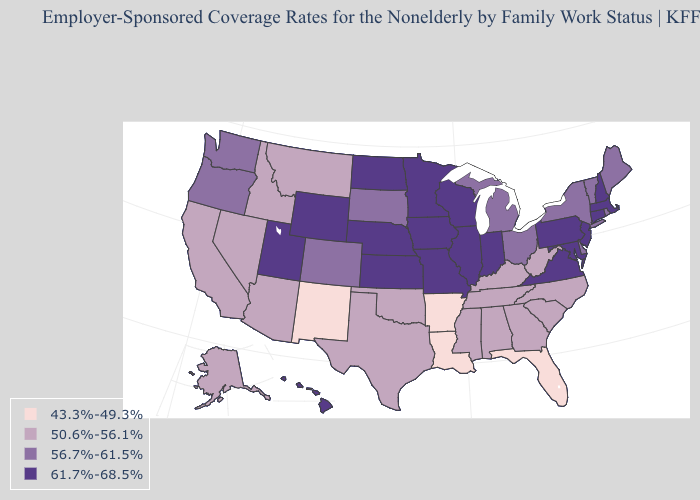What is the highest value in the USA?
Keep it brief. 61.7%-68.5%. What is the lowest value in the USA?
Be succinct. 43.3%-49.3%. Name the states that have a value in the range 61.7%-68.5%?
Quick response, please. Connecticut, Hawaii, Illinois, Indiana, Iowa, Kansas, Maryland, Massachusetts, Minnesota, Missouri, Nebraska, New Hampshire, New Jersey, North Dakota, Pennsylvania, Utah, Virginia, Wisconsin, Wyoming. Among the states that border Missouri , which have the highest value?
Write a very short answer. Illinois, Iowa, Kansas, Nebraska. What is the value of Alabama?
Write a very short answer. 50.6%-56.1%. Among the states that border Washington , does Idaho have the lowest value?
Answer briefly. Yes. What is the value of Kansas?
Give a very brief answer. 61.7%-68.5%. Is the legend a continuous bar?
Quick response, please. No. Does Nebraska have the lowest value in the MidWest?
Quick response, please. No. Is the legend a continuous bar?
Write a very short answer. No. Which states hav the highest value in the MidWest?
Give a very brief answer. Illinois, Indiana, Iowa, Kansas, Minnesota, Missouri, Nebraska, North Dakota, Wisconsin. Name the states that have a value in the range 43.3%-49.3%?
Concise answer only. Arkansas, Florida, Louisiana, New Mexico. Name the states that have a value in the range 43.3%-49.3%?
Answer briefly. Arkansas, Florida, Louisiana, New Mexico. Name the states that have a value in the range 50.6%-56.1%?
Concise answer only. Alabama, Alaska, Arizona, California, Georgia, Idaho, Kentucky, Mississippi, Montana, Nevada, North Carolina, Oklahoma, South Carolina, Tennessee, Texas, West Virginia. Among the states that border New Jersey , which have the highest value?
Quick response, please. Pennsylvania. 